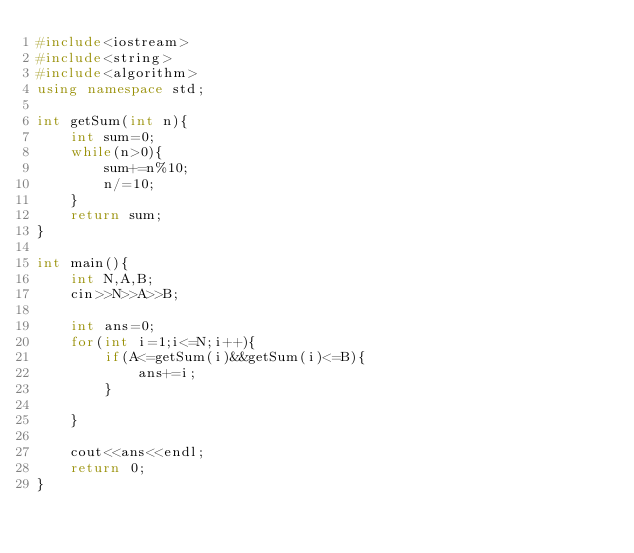<code> <loc_0><loc_0><loc_500><loc_500><_C++_>#include<iostream>
#include<string>
#include<algorithm>
using namespace std;

int getSum(int n){
	int sum=0;
	while(n>0){
		sum+=n%10;
		n/=10;
	}
	return sum;
}

int main(){
	int N,A,B;
	cin>>N>>A>>B;
	
	int ans=0;
	for(int i=1;i<=N;i++){
		if(A<=getSum(i)&&getSum(i)<=B){
			ans+=i;
		}
			
	}
	
	cout<<ans<<endl;
	return 0;
}</code> 